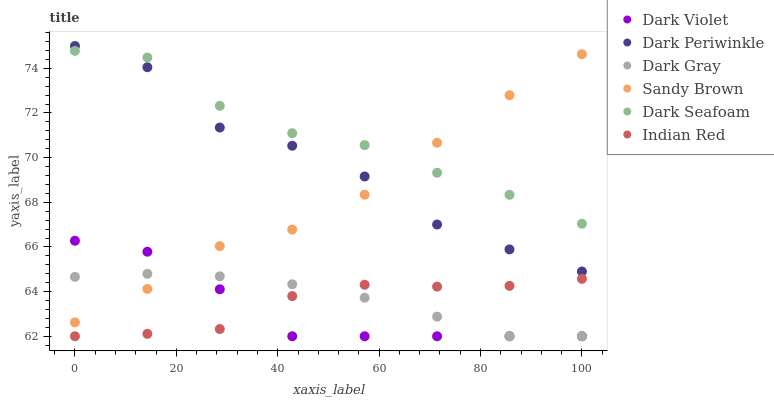Does Dark Violet have the minimum area under the curve?
Answer yes or no. Yes. Does Dark Seafoam have the maximum area under the curve?
Answer yes or no. Yes. Does Dark Gray have the minimum area under the curve?
Answer yes or no. No. Does Dark Gray have the maximum area under the curve?
Answer yes or no. No. Is Dark Gray the smoothest?
Answer yes or no. Yes. Is Dark Periwinkle the roughest?
Answer yes or no. Yes. Is Dark Seafoam the smoothest?
Answer yes or no. No. Is Dark Seafoam the roughest?
Answer yes or no. No. Does Dark Violet have the lowest value?
Answer yes or no. Yes. Does Dark Seafoam have the lowest value?
Answer yes or no. No. Does Dark Periwinkle have the highest value?
Answer yes or no. Yes. Does Dark Gray have the highest value?
Answer yes or no. No. Is Indian Red less than Dark Periwinkle?
Answer yes or no. Yes. Is Dark Seafoam greater than Dark Violet?
Answer yes or no. Yes. Does Dark Gray intersect Dark Violet?
Answer yes or no. Yes. Is Dark Gray less than Dark Violet?
Answer yes or no. No. Is Dark Gray greater than Dark Violet?
Answer yes or no. No. Does Indian Red intersect Dark Periwinkle?
Answer yes or no. No. 